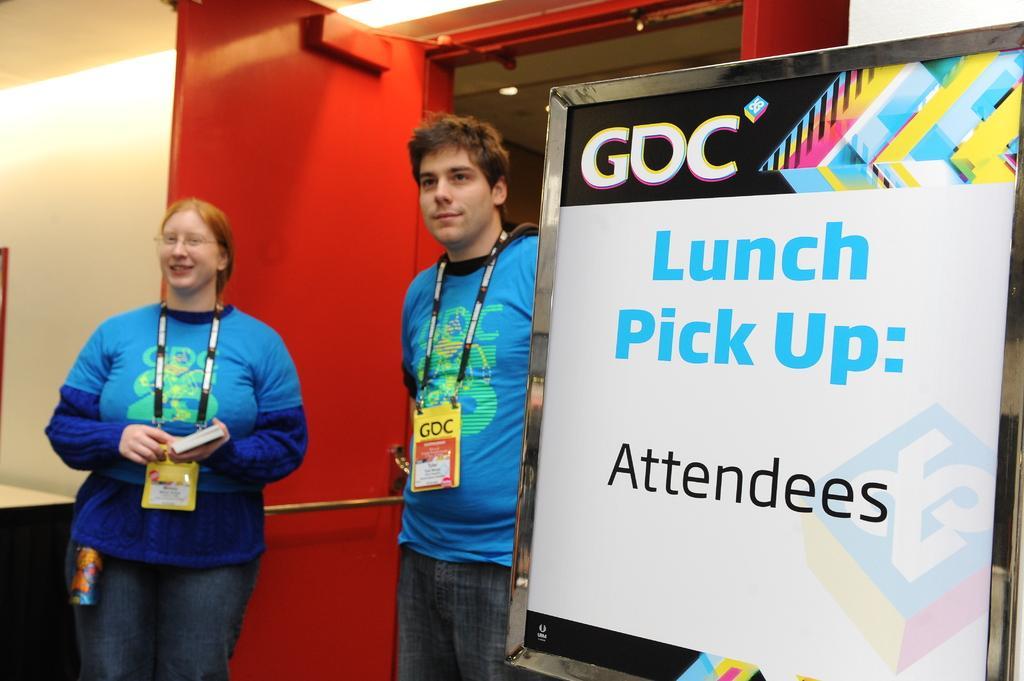Can you describe this image briefly? In this image I can see two persons are standing. I can see both of them are wearing same colour of dress and ID cards. Here I can see white colour board and on it I can see something is written. In the background I can see red colour door. 